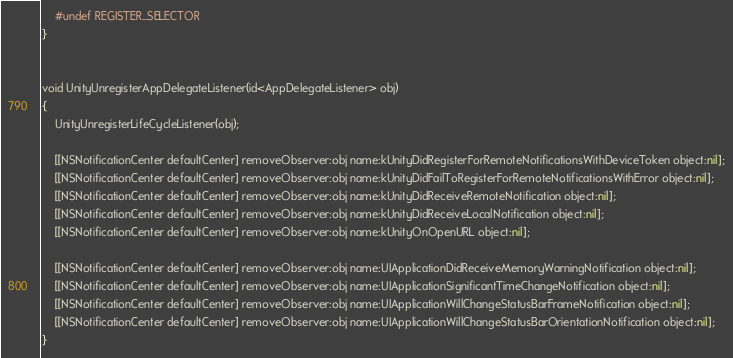Convert code to text. <code><loc_0><loc_0><loc_500><loc_500><_ObjectiveC_>
	#undef REGISTER_SELECTOR
}


void UnityUnregisterAppDelegateListener(id<AppDelegateListener> obj)
{
	UnityUnregisterLifeCycleListener(obj);

	[[NSNotificationCenter defaultCenter] removeObserver:obj name:kUnityDidRegisterForRemoteNotificationsWithDeviceToken object:nil];
	[[NSNotificationCenter defaultCenter] removeObserver:obj name:kUnityDidFailToRegisterForRemoteNotificationsWithError object:nil];
	[[NSNotificationCenter defaultCenter] removeObserver:obj name:kUnityDidReceiveRemoteNotification object:nil];
	[[NSNotificationCenter defaultCenter] removeObserver:obj name:kUnityDidReceiveLocalNotification object:nil];
	[[NSNotificationCenter defaultCenter] removeObserver:obj name:kUnityOnOpenURL object:nil];

	[[NSNotificationCenter defaultCenter] removeObserver:obj name:UIApplicationDidReceiveMemoryWarningNotification object:nil];
	[[NSNotificationCenter defaultCenter] removeObserver:obj name:UIApplicationSignificantTimeChangeNotification object:nil];
	[[NSNotificationCenter defaultCenter] removeObserver:obj name:UIApplicationWillChangeStatusBarFrameNotification object:nil];
	[[NSNotificationCenter defaultCenter] removeObserver:obj name:UIApplicationWillChangeStatusBarOrientationNotification object:nil];
}
</code> 